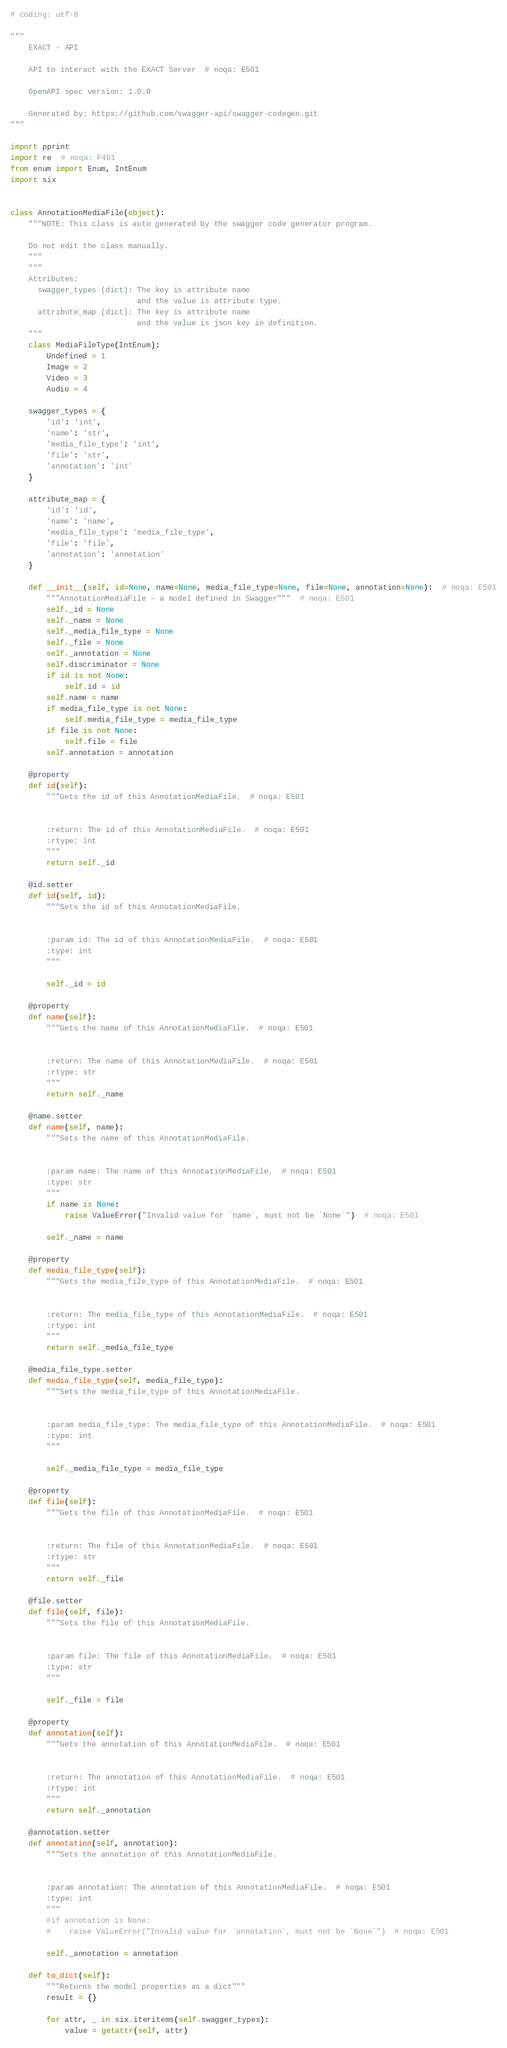<code> <loc_0><loc_0><loc_500><loc_500><_Python_># coding: utf-8

"""
    EXACT - API

    API to interact with the EXACT Server  # noqa: E501

    OpenAPI spec version: 1.0.0
    
    Generated by: https://github.com/swagger-api/swagger-codegen.git
"""

import pprint
import re  # noqa: F401
from enum import Enum, IntEnum
import six


class AnnotationMediaFile(object):
    """NOTE: This class is auto generated by the swagger code generator program.

    Do not edit the class manually.
    """
    """
    Attributes:
      swagger_types (dict): The key is attribute name
                            and the value is attribute type.
      attribute_map (dict): The key is attribute name
                            and the value is json key in definition.
    """
    class MediaFileType(IntEnum):
        Undefined = 1
        Image = 2
        Video = 3
        Audio = 4

    swagger_types = {
        'id': 'int',
        'name': 'str',
        'media_file_type': 'int',
        'file': 'str',
        'annotation': 'int'
    }

    attribute_map = {
        'id': 'id',
        'name': 'name',
        'media_file_type': 'media_file_type',
        'file': 'file',
        'annotation': 'annotation'
    }

    def __init__(self, id=None, name=None, media_file_type=None, file=None, annotation=None):  # noqa: E501
        """AnnotationMediaFile - a model defined in Swagger"""  # noqa: E501
        self._id = None
        self._name = None
        self._media_file_type = None
        self._file = None
        self._annotation = None
        self.discriminator = None
        if id is not None:
            self.id = id
        self.name = name
        if media_file_type is not None:
            self.media_file_type = media_file_type
        if file is not None:
            self.file = file
        self.annotation = annotation

    @property
    def id(self):
        """Gets the id of this AnnotationMediaFile.  # noqa: E501


        :return: The id of this AnnotationMediaFile.  # noqa: E501
        :rtype: int
        """
        return self._id

    @id.setter
    def id(self, id):
        """Sets the id of this AnnotationMediaFile.


        :param id: The id of this AnnotationMediaFile.  # noqa: E501
        :type: int
        """

        self._id = id

    @property
    def name(self):
        """Gets the name of this AnnotationMediaFile.  # noqa: E501


        :return: The name of this AnnotationMediaFile.  # noqa: E501
        :rtype: str
        """
        return self._name

    @name.setter
    def name(self, name):
        """Sets the name of this AnnotationMediaFile.


        :param name: The name of this AnnotationMediaFile.  # noqa: E501
        :type: str
        """
        if name is None:
            raise ValueError("Invalid value for `name`, must not be `None`")  # noqa: E501

        self._name = name

    @property
    def media_file_type(self):
        """Gets the media_file_type of this AnnotationMediaFile.  # noqa: E501


        :return: The media_file_type of this AnnotationMediaFile.  # noqa: E501
        :rtype: int
        """
        return self._media_file_type

    @media_file_type.setter
    def media_file_type(self, media_file_type):
        """Sets the media_file_type of this AnnotationMediaFile.


        :param media_file_type: The media_file_type of this AnnotationMediaFile.  # noqa: E501
        :type: int
        """

        self._media_file_type = media_file_type

    @property
    def file(self):
        """Gets the file of this AnnotationMediaFile.  # noqa: E501


        :return: The file of this AnnotationMediaFile.  # noqa: E501
        :rtype: str
        """
        return self._file

    @file.setter
    def file(self, file):
        """Sets the file of this AnnotationMediaFile.


        :param file: The file of this AnnotationMediaFile.  # noqa: E501
        :type: str
        """

        self._file = file

    @property
    def annotation(self):
        """Gets the annotation of this AnnotationMediaFile.  # noqa: E501


        :return: The annotation of this AnnotationMediaFile.  # noqa: E501
        :rtype: int
        """
        return self._annotation

    @annotation.setter
    def annotation(self, annotation):
        """Sets the annotation of this AnnotationMediaFile.


        :param annotation: The annotation of this AnnotationMediaFile.  # noqa: E501
        :type: int
        """
        #if annotation is None:
        #    raise ValueError("Invalid value for `annotation`, must not be `None`")  # noqa: E501

        self._annotation = annotation

    def to_dict(self):
        """Returns the model properties as a dict"""
        result = {}

        for attr, _ in six.iteritems(self.swagger_types):
            value = getattr(self, attr)</code> 